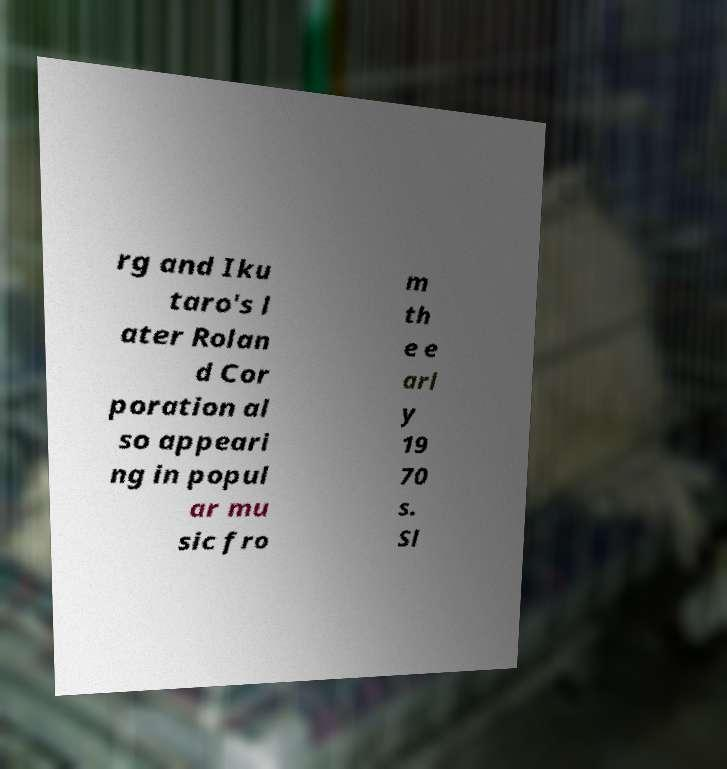Please read and relay the text visible in this image. What does it say? rg and Iku taro's l ater Rolan d Cor poration al so appeari ng in popul ar mu sic fro m th e e arl y 19 70 s. Sl 